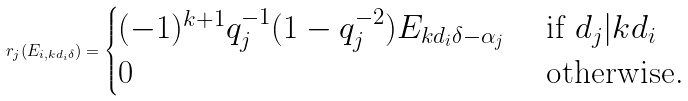<formula> <loc_0><loc_0><loc_500><loc_500>r _ { j } ( E _ { i , k d _ { i } \delta } ) = \begin{cases} ( - 1 ) ^ { k + 1 } q _ { j } ^ { - 1 } ( 1 - q _ { j } ^ { - 2 } ) E _ { k d _ { i } \delta - \alpha _ { j } } & \text { if } d _ { j } | k d _ { i } \\ 0 & \text { otherwise.} \end{cases}</formula> 